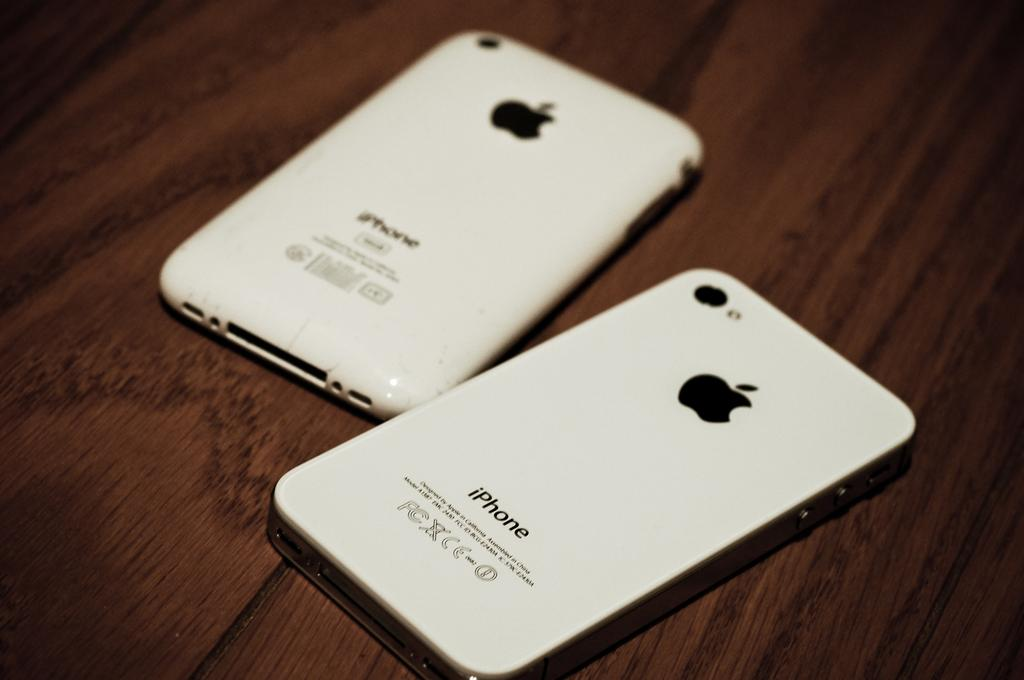<image>
Offer a succinct explanation of the picture presented. The word "iPhone" is placed below the Apple logo. 